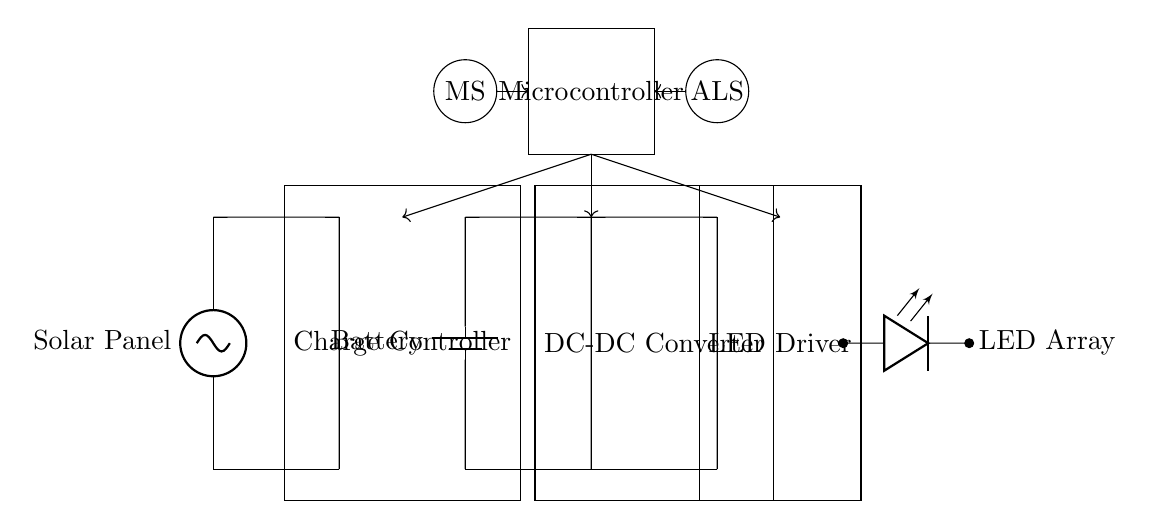What type of energy source is used in this circuit? The circuit uses solar energy, as indicated by the component labeled "Solar Panel" at the beginning of the circuit diagram.
Answer: Solar What device regulates the power flow from the solar panel? The component labeled "Charge Controller" in the circuit is responsible for regulating the power flow from the solar panel to the battery to prevent overcharging.
Answer: Charge Controller How many sensors are included in the circuit? There are two sensors, identified as "Ambient Light Sensor" and "Motion Sensor," depicted with circles in the diagram.
Answer: Two What does the DC-DC Converter do? The DC-DC Converter changes voltage levels to either increase or decrease voltage to appropriate levels for the LED Driver, allowing compatible operation with the battery's voltage.
Answer: Voltage adjustment What is the main output of this circuit intended for? The main output of the circuit is the "LED Array," which is powered by the LED Driver and visually represents the outdoor art exhibit.
Answer: LED Array Which component controls the LED Driver operation? The operation of the LED Driver is controlled by the "Microcontroller," which manages its functionality based on inputs received from the sensors.
Answer: Microcontroller 